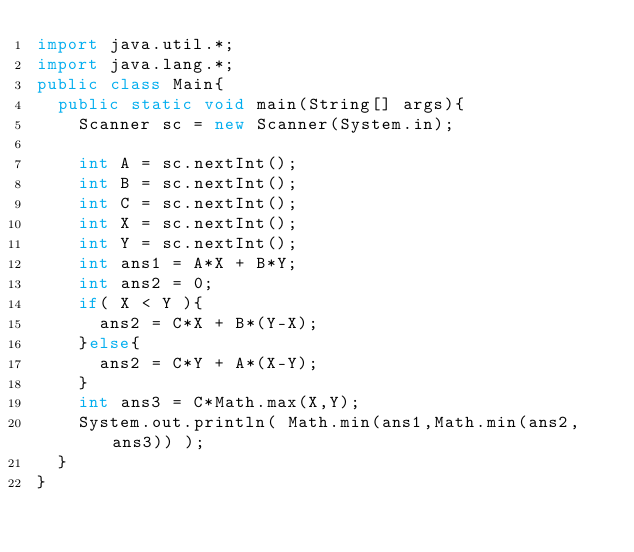<code> <loc_0><loc_0><loc_500><loc_500><_Java_>import java.util.*;
import java.lang.*;
public class Main{
	public static void main(String[] args){
		Scanner sc = new Scanner(System.in);

		int A = sc.nextInt();
		int B = sc.nextInt();
		int C = sc.nextInt();
		int X = sc.nextInt();
		int Y = sc.nextInt();
		int ans1 = A*X + B*Y;
		int ans2 = 0;
		if( X < Y ){
			ans2 = C*X + B*(Y-X);
		}else{
			ans2 = C*Y + A*(X-Y);
		}
		int ans3 = C*Math.max(X,Y);
		System.out.println( Math.min(ans1,Math.min(ans2,ans3)) );
	}
}
</code> 